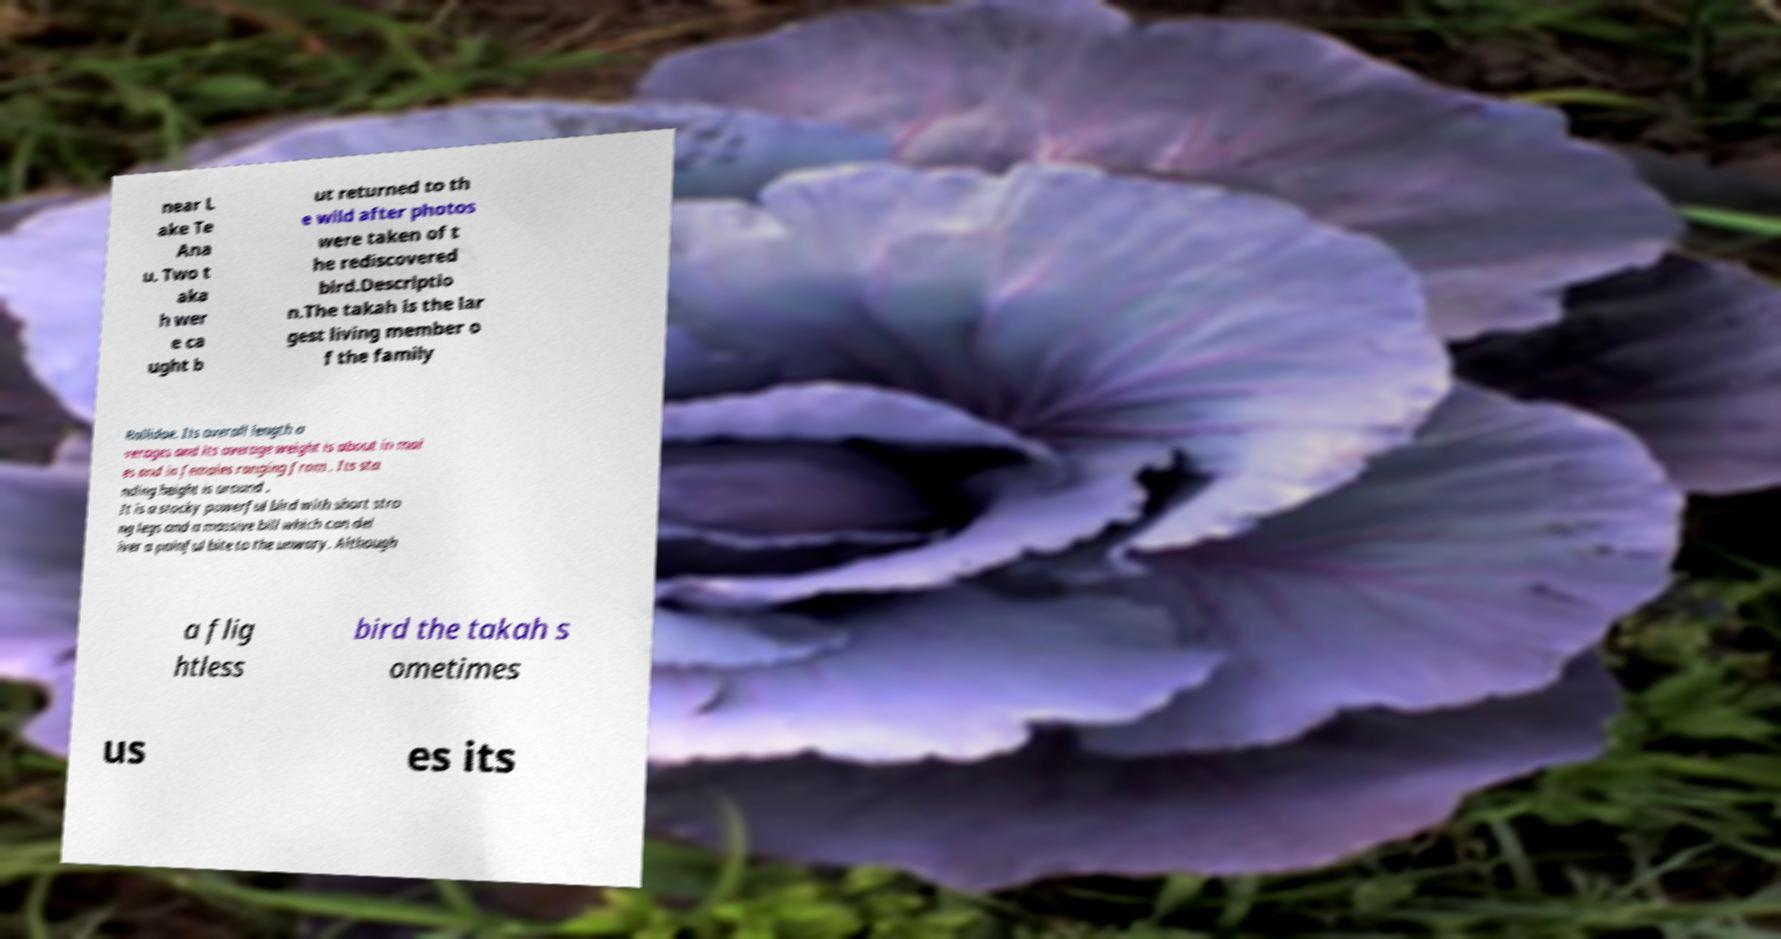There's text embedded in this image that I need extracted. Can you transcribe it verbatim? near L ake Te Ana u. Two t aka h wer e ca ught b ut returned to th e wild after photos were taken of t he rediscovered bird.Descriptio n.The takah is the lar gest living member o f the family Rallidae. Its overall length a verages and its average weight is about in mal es and in females ranging from . Its sta nding height is around . It is a stocky powerful bird with short stro ng legs and a massive bill which can del iver a painful bite to the unwary. Although a flig htless bird the takah s ometimes us es its 